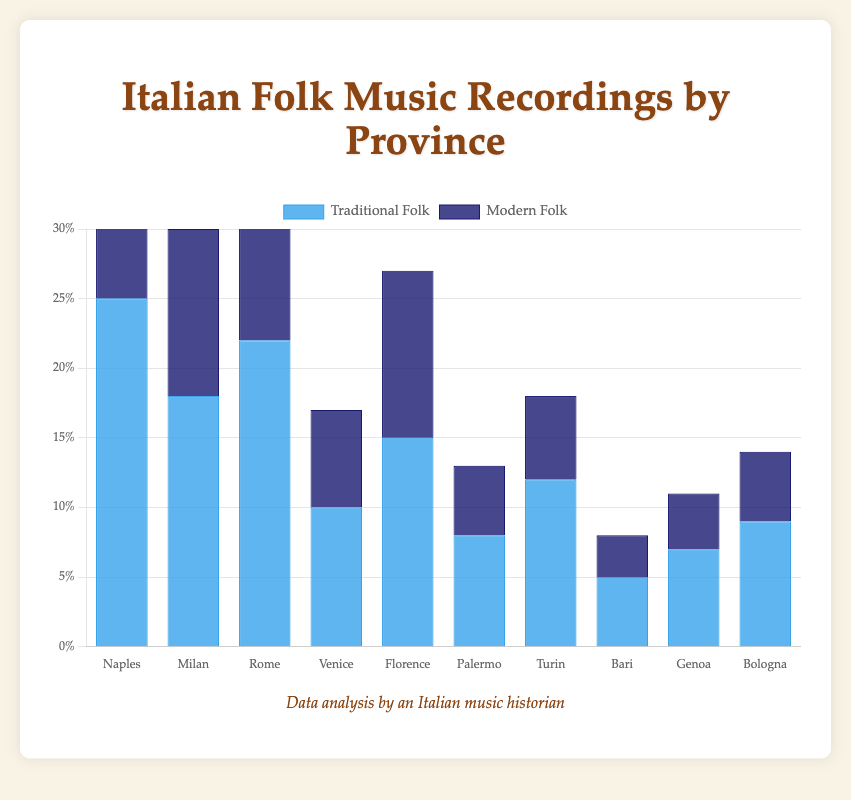Which province records the highest percentage of Traditional Folk music? By looking at the heights of the blue bars, Naples has the highest percentage at 25%.
Answer: Naples Which province records the lowest percentage of Modern Folk music? By examining the dark blue bars, Bari records the lowest percentage at 3%.
Answer: Bari What is the total percentage of folk music recordings (Traditional and Modern) in Venice? The sum of the blue bar (10%) and the dark blue bar (7%) for Venice is 10% + 7% = 17%.
Answer: 17% How does the percentage of Modern Folk music in Florence compare to that in Rome? The dark blue bar for Florence shows 12% and for Rome shows 10%, so Florence has a higher percentage by 2%.
Answer: Florence has 2% more Which has a higher percentage of Total Folk music recordings: Milan or Turin? Sum the blue and dark blue positions for each. Milan: 18% + 12% = 30%. Turin: 12% + 6% = 18%. Milan's total is higher.
Answer: Milan What is the average percentage of Modern Folk music recordings across all provinces? Sum all dark blue percentages (15+12+10+7+12+5+6+3+4+5 = 79) and divide by 10 (10 provinces), resulting in an average percentage of 7.9%.
Answer: 7.9% Which province has the third highest percentage of Traditional Folk music? By ordering the blue bars from highest to lowest: Naples (25%), Rome (22%), Milan (18%). Milan is the third highest.
Answer: Milan Is the percentage of Traditional Folk music in Genoa more than or less than double the percentage of Modern Folk music in Palermo? Traditional in Genoa is 7%. Modern in Palermo is 5%. Double of Palermo's Modern is 10%. Comparing 7% (Genoa) to 10% (double Palermo's Modern), Genoa's Traditional is less.
Answer: Less What is the difference in the percentage of Modern Folk music recordings between Venice and Bologna? Subtract the dark blue percentage of Bologna (5%) from Venice (7%), giving a difference of 2%.
Answer: 2% 